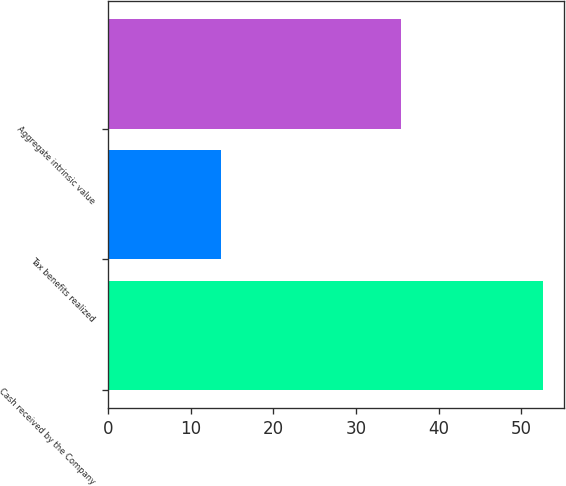Convert chart. <chart><loc_0><loc_0><loc_500><loc_500><bar_chart><fcel>Cash received by the Company<fcel>Tax benefits realized<fcel>Aggregate intrinsic value<nl><fcel>52.6<fcel>13.6<fcel>35.5<nl></chart> 